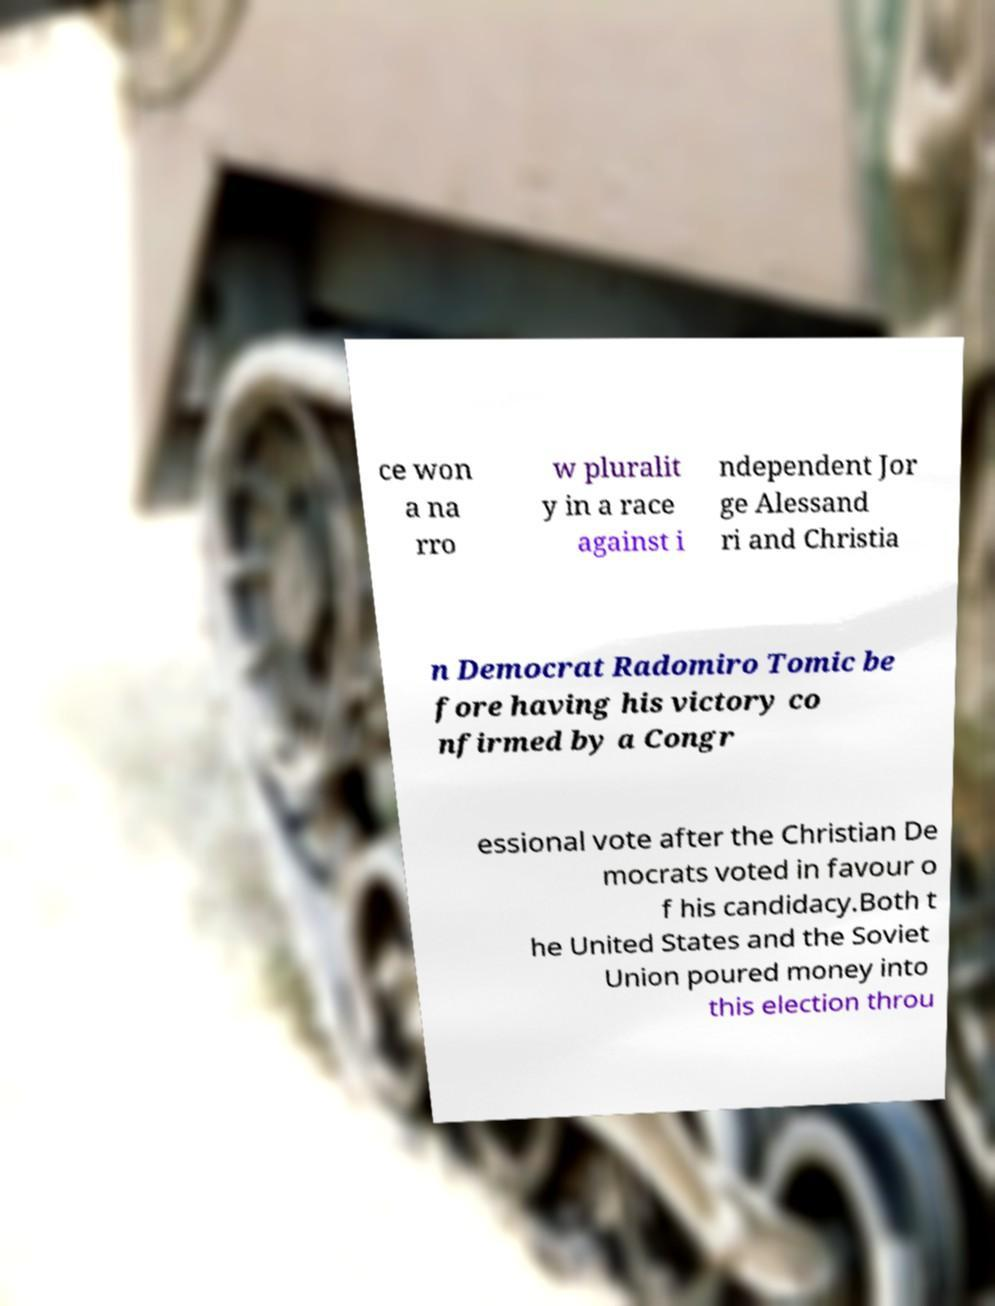I need the written content from this picture converted into text. Can you do that? ce won a na rro w pluralit y in a race against i ndependent Jor ge Alessand ri and Christia n Democrat Radomiro Tomic be fore having his victory co nfirmed by a Congr essional vote after the Christian De mocrats voted in favour o f his candidacy.Both t he United States and the Soviet Union poured money into this election throu 